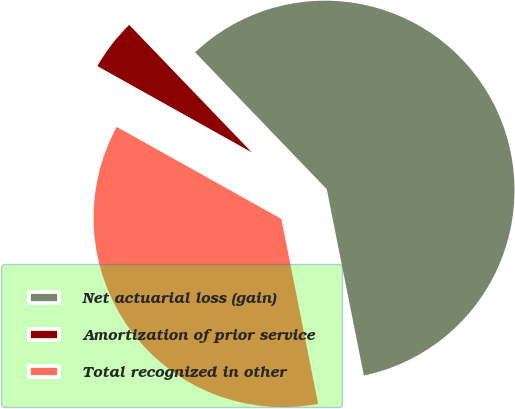Convert chart. <chart><loc_0><loc_0><loc_500><loc_500><pie_chart><fcel>Net actuarial loss (gain)<fcel>Amortization of prior service<fcel>Total recognized in other<nl><fcel>59.06%<fcel>4.7%<fcel>36.24%<nl></chart> 